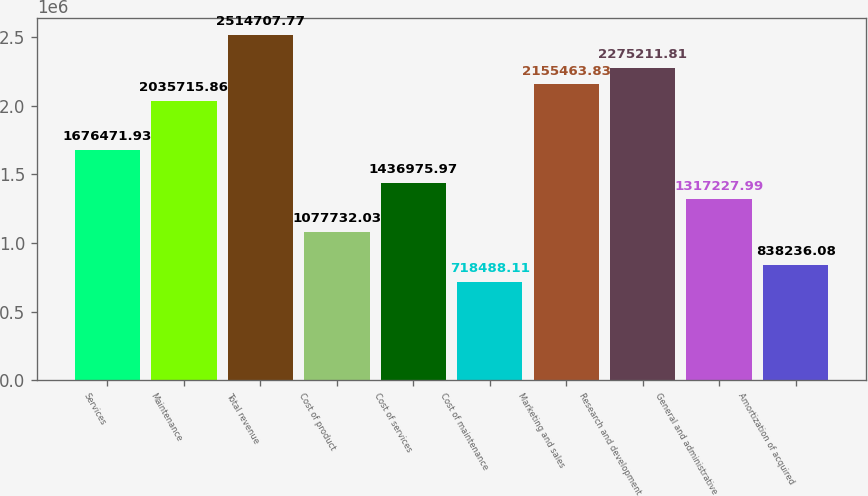<chart> <loc_0><loc_0><loc_500><loc_500><bar_chart><fcel>Services<fcel>Maintenance<fcel>Total revenue<fcel>Cost of product<fcel>Cost of services<fcel>Cost of maintenance<fcel>Marketing and sales<fcel>Research and development<fcel>General and administrative<fcel>Amortization of acquired<nl><fcel>1.67647e+06<fcel>2.03572e+06<fcel>2.51471e+06<fcel>1.07773e+06<fcel>1.43698e+06<fcel>718488<fcel>2.15546e+06<fcel>2.27521e+06<fcel>1.31723e+06<fcel>838236<nl></chart> 